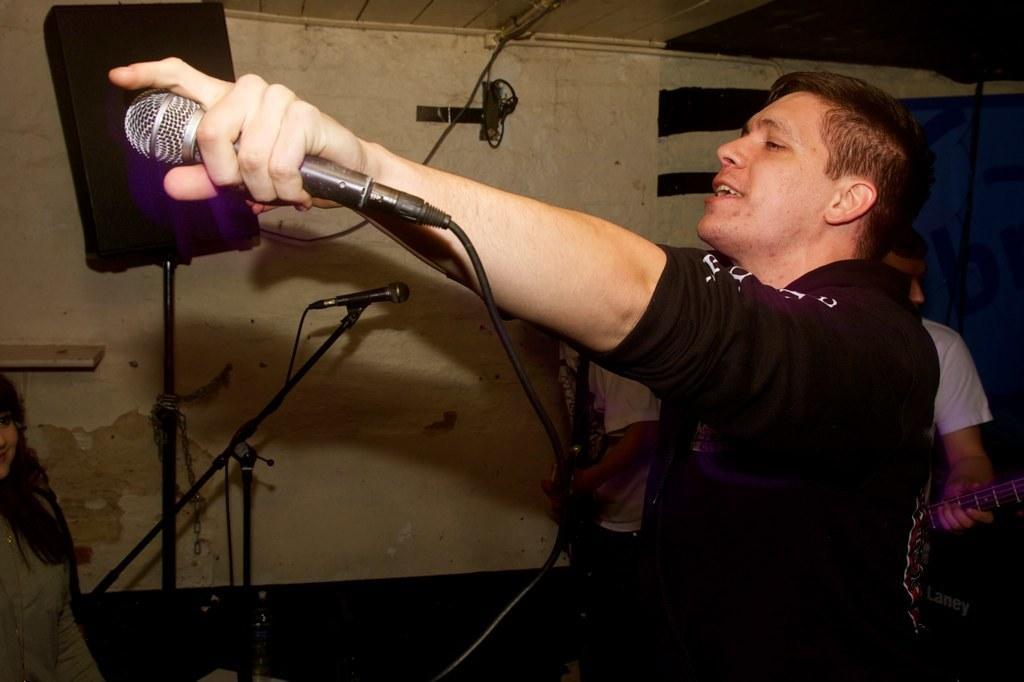Could you give a brief overview of what you see in this image? In this image I can see few people with white and black color dresses. I can see one person holding the mic and two people with musical instruments. To the left I can see another person. In the background I can see the sound box, mic and the wall. I can also see the blue color object to the right. 